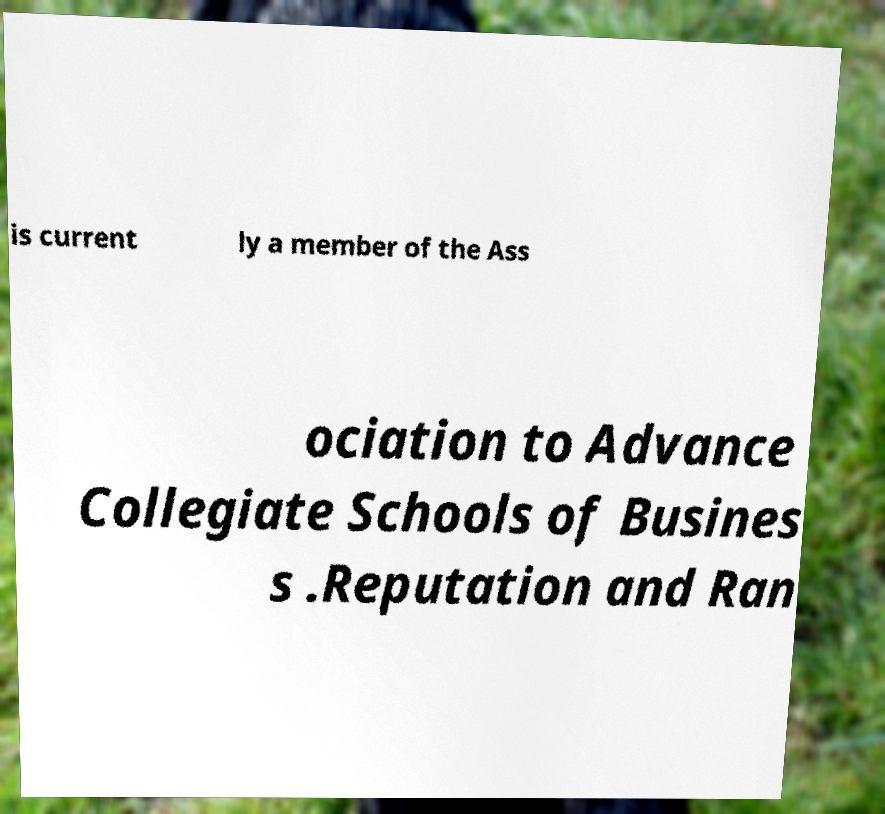Please read and relay the text visible in this image. What does it say? is current ly a member of the Ass ociation to Advance Collegiate Schools of Busines s .Reputation and Ran 